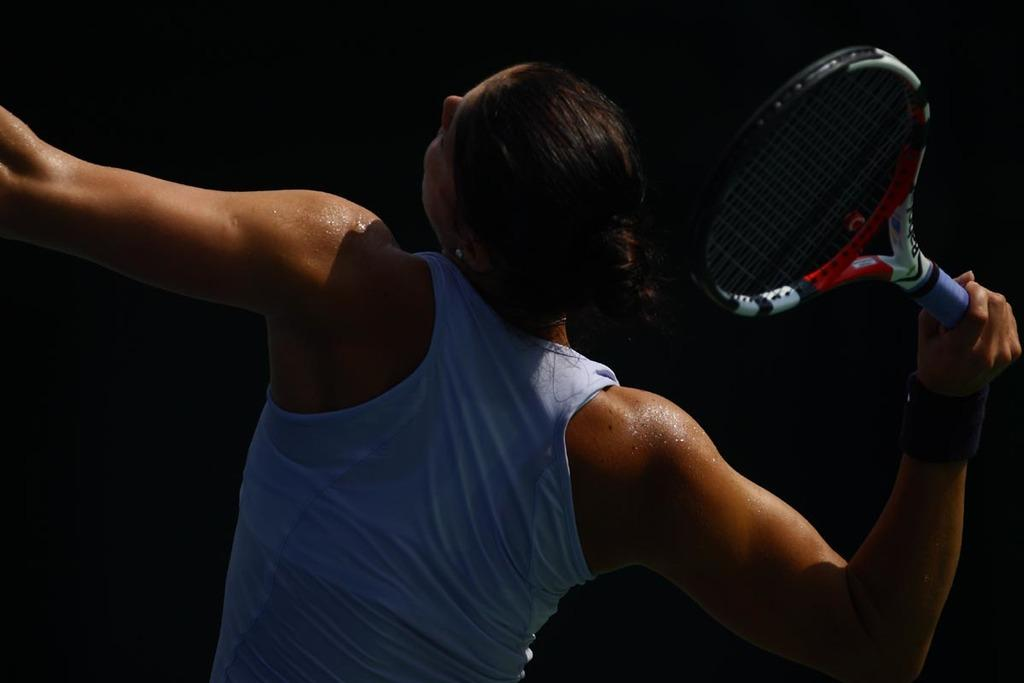What is the main subject of the image? There is a person in the image. What is the person holding in his hand? The person is holding a racket in his hand. What color is the background of the image? The background of the image is black. Can you see any pipes in the image? There are no pipes present in the image. What type of sail is visible in the image? There is no sail present in the image. 